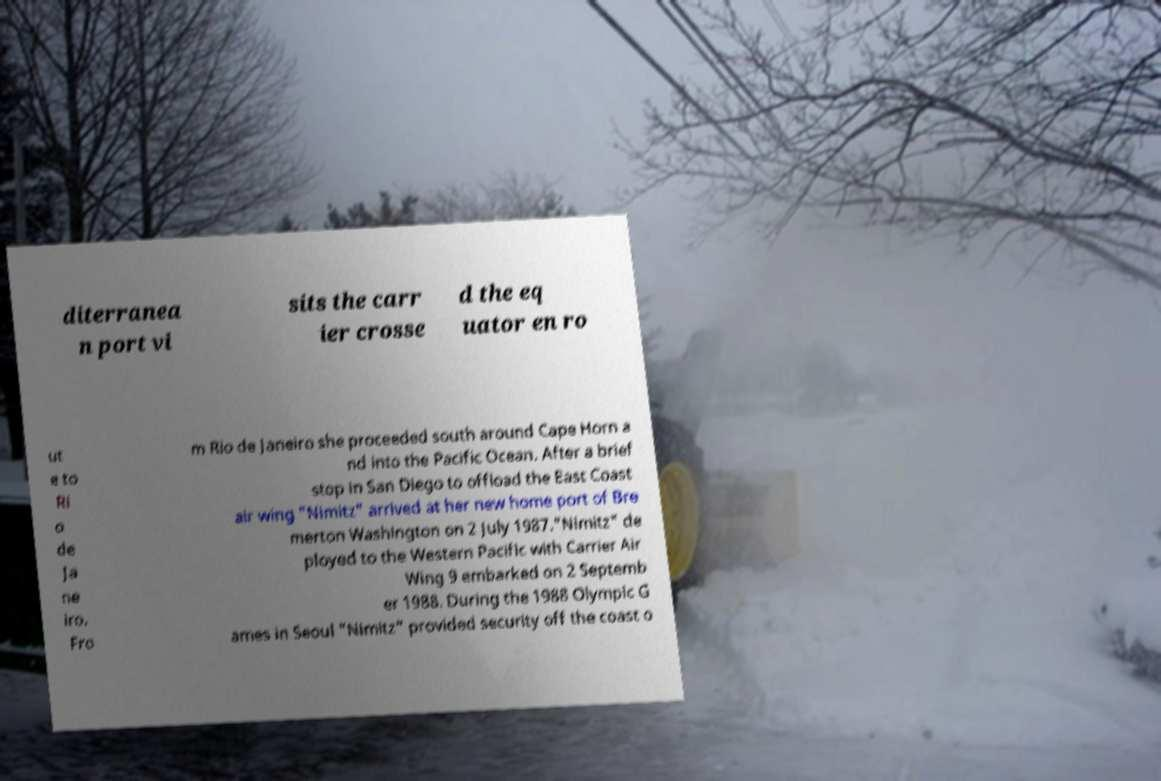Please read and relay the text visible in this image. What does it say? diterranea n port vi sits the carr ier crosse d the eq uator en ro ut e to Ri o de Ja ne iro. Fro m Rio de Janeiro she proceeded south around Cape Horn a nd into the Pacific Ocean. After a brief stop in San Diego to offload the East Coast air wing "Nimitz" arrived at her new home port of Bre merton Washington on 2 July 1987."Nimitz" de ployed to the Western Pacific with Carrier Air Wing 9 embarked on 2 Septemb er 1988. During the 1988 Olympic G ames in Seoul "Nimitz" provided security off the coast o 